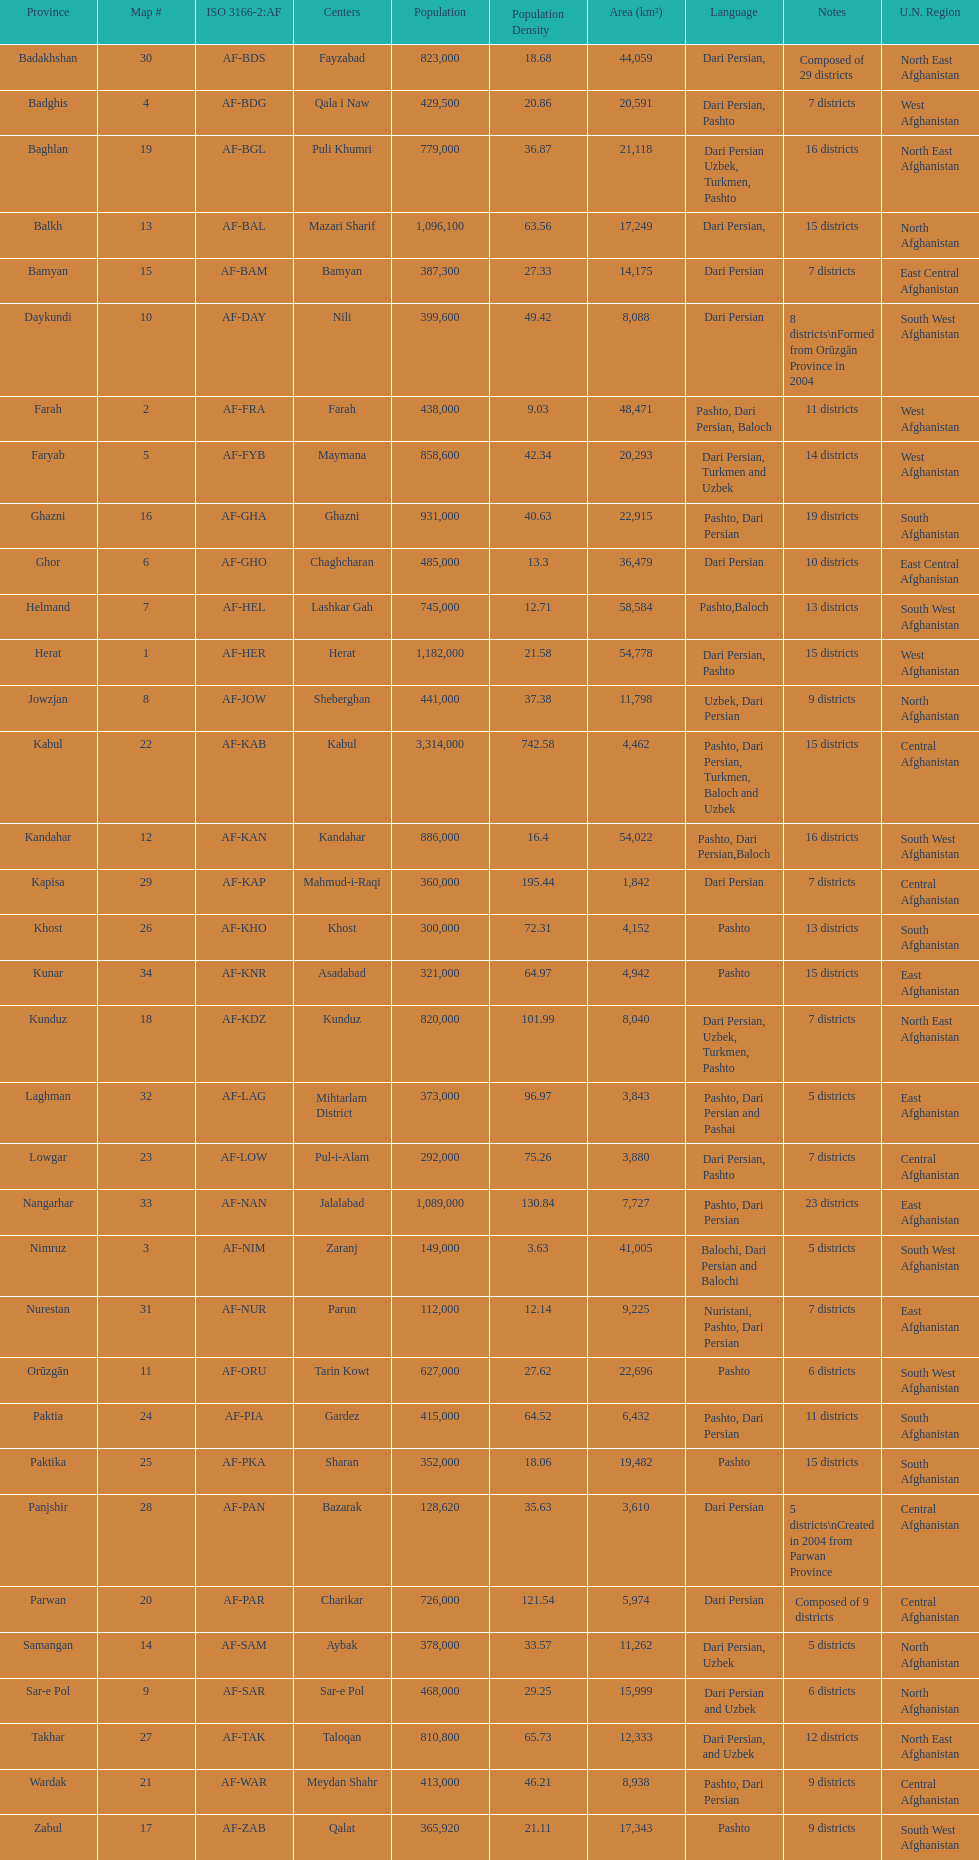Give the province with the least population Nurestan. 